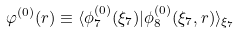Convert formula to latex. <formula><loc_0><loc_0><loc_500><loc_500>\varphi ^ { ( 0 ) } ( { r } ) \equiv \langle \phi ^ { ( 0 ) } _ { 7 } ( \xi _ { 7 } ) | \phi ^ { ( 0 ) } _ { 8 } ( \xi _ { 7 } , { r } ) \rangle _ { \xi _ { 7 } }</formula> 